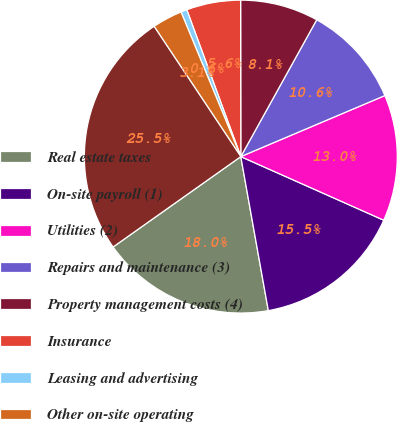Convert chart. <chart><loc_0><loc_0><loc_500><loc_500><pie_chart><fcel>Real estate taxes<fcel>On-site payroll (1)<fcel>Utilities (2)<fcel>Repairs and maintenance (3)<fcel>Property management costs (4)<fcel>Insurance<fcel>Leasing and advertising<fcel>Other on-site operating<fcel>Same store operating expenses<nl><fcel>18.01%<fcel>15.52%<fcel>13.04%<fcel>10.56%<fcel>8.08%<fcel>5.59%<fcel>0.63%<fcel>3.11%<fcel>25.45%<nl></chart> 